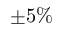<formula> <loc_0><loc_0><loc_500><loc_500>\pm 5 \%</formula> 